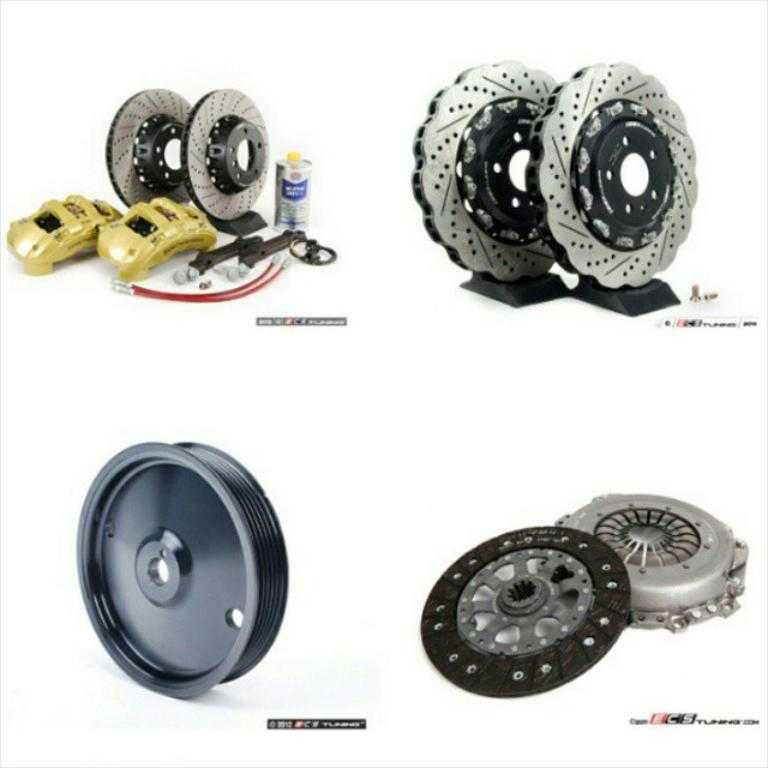What type of car parts can be seen in the image? There are brake discs and other car parts visible in the image. What is the color of the background in the image? The background of the image is white. Can you describe the objects in the image? The objects in the image are car parts, including brake discs. What letter is written on the top of the brake discs in the image? There is no letter written on the top of the brake discs in the image. How does the adjustment of the brake discs affect the car's performance in the image? The image does not show the brake discs in use or provide any information about their adjustment, so we cannot determine how it affects the car's performance. 